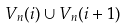Convert formula to latex. <formula><loc_0><loc_0><loc_500><loc_500>V _ { n } ( i ) \cup V _ { n } ( i + 1 )</formula> 